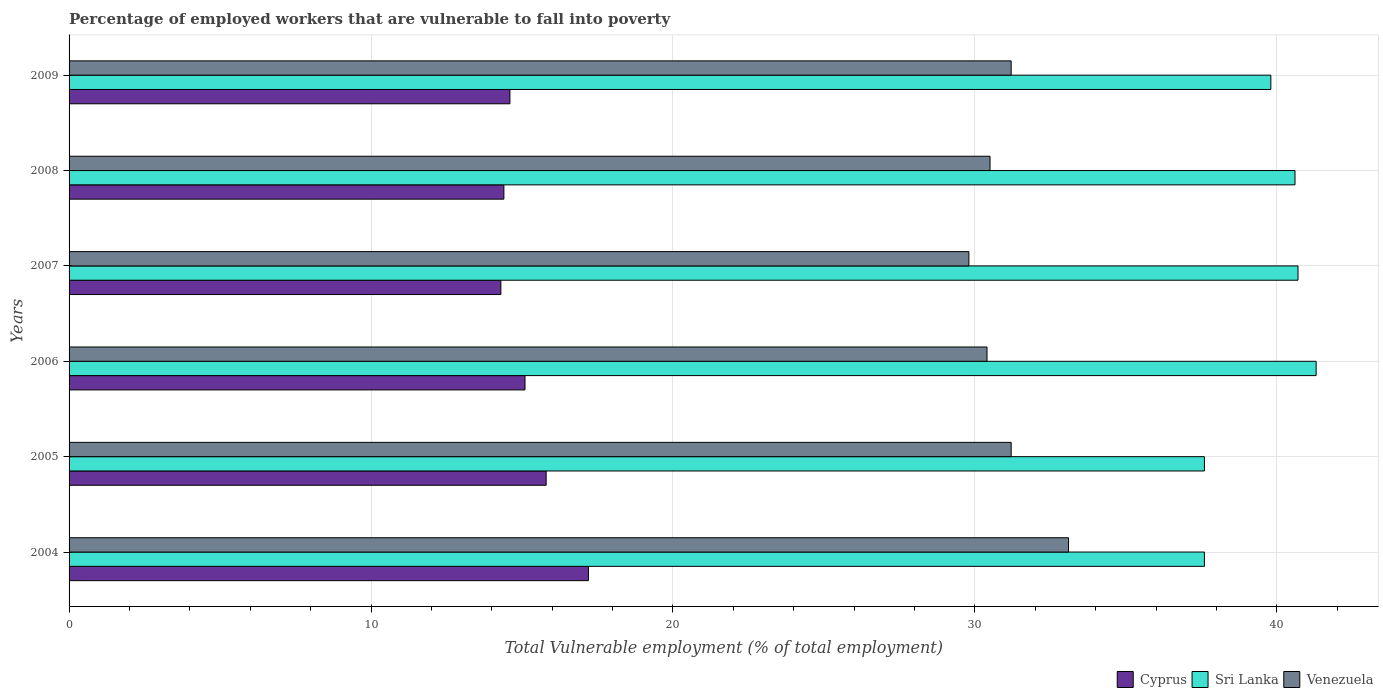How many different coloured bars are there?
Keep it short and to the point. 3. How many groups of bars are there?
Your answer should be compact. 6. Are the number of bars per tick equal to the number of legend labels?
Keep it short and to the point. Yes. What is the label of the 6th group of bars from the top?
Provide a short and direct response. 2004. What is the percentage of employed workers who are vulnerable to fall into poverty in Venezuela in 2009?
Keep it short and to the point. 31.2. Across all years, what is the maximum percentage of employed workers who are vulnerable to fall into poverty in Venezuela?
Ensure brevity in your answer.  33.1. Across all years, what is the minimum percentage of employed workers who are vulnerable to fall into poverty in Venezuela?
Offer a terse response. 29.8. In which year was the percentage of employed workers who are vulnerable to fall into poverty in Venezuela minimum?
Your answer should be very brief. 2007. What is the total percentage of employed workers who are vulnerable to fall into poverty in Venezuela in the graph?
Your answer should be very brief. 186.2. What is the difference between the percentage of employed workers who are vulnerable to fall into poverty in Sri Lanka in 2006 and that in 2007?
Make the answer very short. 0.6. What is the difference between the percentage of employed workers who are vulnerable to fall into poverty in Venezuela in 2009 and the percentage of employed workers who are vulnerable to fall into poverty in Cyprus in 2008?
Offer a terse response. 16.8. What is the average percentage of employed workers who are vulnerable to fall into poverty in Venezuela per year?
Give a very brief answer. 31.03. In the year 2008, what is the difference between the percentage of employed workers who are vulnerable to fall into poverty in Sri Lanka and percentage of employed workers who are vulnerable to fall into poverty in Venezuela?
Your response must be concise. 10.1. In how many years, is the percentage of employed workers who are vulnerable to fall into poverty in Sri Lanka greater than 38 %?
Your answer should be very brief. 4. What is the ratio of the percentage of employed workers who are vulnerable to fall into poverty in Cyprus in 2008 to that in 2009?
Ensure brevity in your answer.  0.99. What is the difference between the highest and the second highest percentage of employed workers who are vulnerable to fall into poverty in Venezuela?
Provide a short and direct response. 1.9. What is the difference between the highest and the lowest percentage of employed workers who are vulnerable to fall into poverty in Sri Lanka?
Keep it short and to the point. 3.7. Is the sum of the percentage of employed workers who are vulnerable to fall into poverty in Sri Lanka in 2005 and 2008 greater than the maximum percentage of employed workers who are vulnerable to fall into poverty in Venezuela across all years?
Provide a succinct answer. Yes. What does the 1st bar from the top in 2005 represents?
Offer a very short reply. Venezuela. What does the 3rd bar from the bottom in 2005 represents?
Ensure brevity in your answer.  Venezuela. Is it the case that in every year, the sum of the percentage of employed workers who are vulnerable to fall into poverty in Cyprus and percentage of employed workers who are vulnerable to fall into poverty in Sri Lanka is greater than the percentage of employed workers who are vulnerable to fall into poverty in Venezuela?
Your response must be concise. Yes. Are all the bars in the graph horizontal?
Your answer should be very brief. Yes. What is the difference between two consecutive major ticks on the X-axis?
Ensure brevity in your answer.  10. Are the values on the major ticks of X-axis written in scientific E-notation?
Provide a succinct answer. No. Does the graph contain grids?
Provide a short and direct response. Yes. How many legend labels are there?
Ensure brevity in your answer.  3. How are the legend labels stacked?
Offer a very short reply. Horizontal. What is the title of the graph?
Provide a short and direct response. Percentage of employed workers that are vulnerable to fall into poverty. Does "United Arab Emirates" appear as one of the legend labels in the graph?
Provide a short and direct response. No. What is the label or title of the X-axis?
Keep it short and to the point. Total Vulnerable employment (% of total employment). What is the label or title of the Y-axis?
Your answer should be compact. Years. What is the Total Vulnerable employment (% of total employment) in Cyprus in 2004?
Your answer should be very brief. 17.2. What is the Total Vulnerable employment (% of total employment) in Sri Lanka in 2004?
Keep it short and to the point. 37.6. What is the Total Vulnerable employment (% of total employment) in Venezuela in 2004?
Keep it short and to the point. 33.1. What is the Total Vulnerable employment (% of total employment) in Cyprus in 2005?
Offer a very short reply. 15.8. What is the Total Vulnerable employment (% of total employment) in Sri Lanka in 2005?
Your answer should be very brief. 37.6. What is the Total Vulnerable employment (% of total employment) of Venezuela in 2005?
Your answer should be compact. 31.2. What is the Total Vulnerable employment (% of total employment) in Cyprus in 2006?
Ensure brevity in your answer.  15.1. What is the Total Vulnerable employment (% of total employment) of Sri Lanka in 2006?
Provide a short and direct response. 41.3. What is the Total Vulnerable employment (% of total employment) in Venezuela in 2006?
Provide a short and direct response. 30.4. What is the Total Vulnerable employment (% of total employment) in Cyprus in 2007?
Provide a succinct answer. 14.3. What is the Total Vulnerable employment (% of total employment) of Sri Lanka in 2007?
Provide a short and direct response. 40.7. What is the Total Vulnerable employment (% of total employment) of Venezuela in 2007?
Provide a succinct answer. 29.8. What is the Total Vulnerable employment (% of total employment) of Cyprus in 2008?
Offer a very short reply. 14.4. What is the Total Vulnerable employment (% of total employment) of Sri Lanka in 2008?
Provide a short and direct response. 40.6. What is the Total Vulnerable employment (% of total employment) in Venezuela in 2008?
Your answer should be very brief. 30.5. What is the Total Vulnerable employment (% of total employment) of Cyprus in 2009?
Ensure brevity in your answer.  14.6. What is the Total Vulnerable employment (% of total employment) of Sri Lanka in 2009?
Give a very brief answer. 39.8. What is the Total Vulnerable employment (% of total employment) of Venezuela in 2009?
Ensure brevity in your answer.  31.2. Across all years, what is the maximum Total Vulnerable employment (% of total employment) of Cyprus?
Provide a short and direct response. 17.2. Across all years, what is the maximum Total Vulnerable employment (% of total employment) in Sri Lanka?
Make the answer very short. 41.3. Across all years, what is the maximum Total Vulnerable employment (% of total employment) in Venezuela?
Your answer should be very brief. 33.1. Across all years, what is the minimum Total Vulnerable employment (% of total employment) of Cyprus?
Your answer should be very brief. 14.3. Across all years, what is the minimum Total Vulnerable employment (% of total employment) of Sri Lanka?
Give a very brief answer. 37.6. Across all years, what is the minimum Total Vulnerable employment (% of total employment) in Venezuela?
Offer a terse response. 29.8. What is the total Total Vulnerable employment (% of total employment) in Cyprus in the graph?
Provide a succinct answer. 91.4. What is the total Total Vulnerable employment (% of total employment) in Sri Lanka in the graph?
Keep it short and to the point. 237.6. What is the total Total Vulnerable employment (% of total employment) in Venezuela in the graph?
Offer a terse response. 186.2. What is the difference between the Total Vulnerable employment (% of total employment) of Cyprus in 2004 and that in 2005?
Provide a succinct answer. 1.4. What is the difference between the Total Vulnerable employment (% of total employment) in Venezuela in 2004 and that in 2005?
Ensure brevity in your answer.  1.9. What is the difference between the Total Vulnerable employment (% of total employment) in Venezuela in 2004 and that in 2006?
Offer a very short reply. 2.7. What is the difference between the Total Vulnerable employment (% of total employment) of Cyprus in 2004 and that in 2007?
Offer a terse response. 2.9. What is the difference between the Total Vulnerable employment (% of total employment) in Sri Lanka in 2004 and that in 2007?
Your answer should be compact. -3.1. What is the difference between the Total Vulnerable employment (% of total employment) in Venezuela in 2004 and that in 2007?
Provide a succinct answer. 3.3. What is the difference between the Total Vulnerable employment (% of total employment) in Sri Lanka in 2004 and that in 2008?
Make the answer very short. -3. What is the difference between the Total Vulnerable employment (% of total employment) in Venezuela in 2004 and that in 2008?
Provide a short and direct response. 2.6. What is the difference between the Total Vulnerable employment (% of total employment) in Venezuela in 2004 and that in 2009?
Keep it short and to the point. 1.9. What is the difference between the Total Vulnerable employment (% of total employment) in Cyprus in 2005 and that in 2006?
Keep it short and to the point. 0.7. What is the difference between the Total Vulnerable employment (% of total employment) in Cyprus in 2005 and that in 2007?
Offer a very short reply. 1.5. What is the difference between the Total Vulnerable employment (% of total employment) of Venezuela in 2005 and that in 2007?
Your answer should be very brief. 1.4. What is the difference between the Total Vulnerable employment (% of total employment) of Sri Lanka in 2005 and that in 2008?
Your response must be concise. -3. What is the difference between the Total Vulnerable employment (% of total employment) in Sri Lanka in 2005 and that in 2009?
Offer a very short reply. -2.2. What is the difference between the Total Vulnerable employment (% of total employment) in Cyprus in 2006 and that in 2007?
Give a very brief answer. 0.8. What is the difference between the Total Vulnerable employment (% of total employment) in Sri Lanka in 2006 and that in 2008?
Provide a succinct answer. 0.7. What is the difference between the Total Vulnerable employment (% of total employment) of Venezuela in 2006 and that in 2008?
Your response must be concise. -0.1. What is the difference between the Total Vulnerable employment (% of total employment) in Sri Lanka in 2006 and that in 2009?
Provide a short and direct response. 1.5. What is the difference between the Total Vulnerable employment (% of total employment) of Venezuela in 2006 and that in 2009?
Provide a succinct answer. -0.8. What is the difference between the Total Vulnerable employment (% of total employment) in Sri Lanka in 2007 and that in 2008?
Your response must be concise. 0.1. What is the difference between the Total Vulnerable employment (% of total employment) in Venezuela in 2007 and that in 2008?
Offer a terse response. -0.7. What is the difference between the Total Vulnerable employment (% of total employment) of Cyprus in 2007 and that in 2009?
Your response must be concise. -0.3. What is the difference between the Total Vulnerable employment (% of total employment) in Sri Lanka in 2007 and that in 2009?
Ensure brevity in your answer.  0.9. What is the difference between the Total Vulnerable employment (% of total employment) of Venezuela in 2007 and that in 2009?
Offer a terse response. -1.4. What is the difference between the Total Vulnerable employment (% of total employment) in Cyprus in 2008 and that in 2009?
Ensure brevity in your answer.  -0.2. What is the difference between the Total Vulnerable employment (% of total employment) in Sri Lanka in 2008 and that in 2009?
Your response must be concise. 0.8. What is the difference between the Total Vulnerable employment (% of total employment) in Venezuela in 2008 and that in 2009?
Keep it short and to the point. -0.7. What is the difference between the Total Vulnerable employment (% of total employment) of Cyprus in 2004 and the Total Vulnerable employment (% of total employment) of Sri Lanka in 2005?
Provide a succinct answer. -20.4. What is the difference between the Total Vulnerable employment (% of total employment) in Sri Lanka in 2004 and the Total Vulnerable employment (% of total employment) in Venezuela in 2005?
Your response must be concise. 6.4. What is the difference between the Total Vulnerable employment (% of total employment) in Cyprus in 2004 and the Total Vulnerable employment (% of total employment) in Sri Lanka in 2006?
Ensure brevity in your answer.  -24.1. What is the difference between the Total Vulnerable employment (% of total employment) in Cyprus in 2004 and the Total Vulnerable employment (% of total employment) in Venezuela in 2006?
Offer a terse response. -13.2. What is the difference between the Total Vulnerable employment (% of total employment) of Cyprus in 2004 and the Total Vulnerable employment (% of total employment) of Sri Lanka in 2007?
Your answer should be very brief. -23.5. What is the difference between the Total Vulnerable employment (% of total employment) in Sri Lanka in 2004 and the Total Vulnerable employment (% of total employment) in Venezuela in 2007?
Make the answer very short. 7.8. What is the difference between the Total Vulnerable employment (% of total employment) of Cyprus in 2004 and the Total Vulnerable employment (% of total employment) of Sri Lanka in 2008?
Keep it short and to the point. -23.4. What is the difference between the Total Vulnerable employment (% of total employment) in Cyprus in 2004 and the Total Vulnerable employment (% of total employment) in Venezuela in 2008?
Your answer should be compact. -13.3. What is the difference between the Total Vulnerable employment (% of total employment) in Cyprus in 2004 and the Total Vulnerable employment (% of total employment) in Sri Lanka in 2009?
Your answer should be compact. -22.6. What is the difference between the Total Vulnerable employment (% of total employment) in Cyprus in 2004 and the Total Vulnerable employment (% of total employment) in Venezuela in 2009?
Provide a short and direct response. -14. What is the difference between the Total Vulnerable employment (% of total employment) in Cyprus in 2005 and the Total Vulnerable employment (% of total employment) in Sri Lanka in 2006?
Offer a terse response. -25.5. What is the difference between the Total Vulnerable employment (% of total employment) in Cyprus in 2005 and the Total Vulnerable employment (% of total employment) in Venezuela in 2006?
Your answer should be very brief. -14.6. What is the difference between the Total Vulnerable employment (% of total employment) in Sri Lanka in 2005 and the Total Vulnerable employment (% of total employment) in Venezuela in 2006?
Your response must be concise. 7.2. What is the difference between the Total Vulnerable employment (% of total employment) in Cyprus in 2005 and the Total Vulnerable employment (% of total employment) in Sri Lanka in 2007?
Offer a very short reply. -24.9. What is the difference between the Total Vulnerable employment (% of total employment) in Cyprus in 2005 and the Total Vulnerable employment (% of total employment) in Venezuela in 2007?
Your response must be concise. -14. What is the difference between the Total Vulnerable employment (% of total employment) of Cyprus in 2005 and the Total Vulnerable employment (% of total employment) of Sri Lanka in 2008?
Ensure brevity in your answer.  -24.8. What is the difference between the Total Vulnerable employment (% of total employment) of Cyprus in 2005 and the Total Vulnerable employment (% of total employment) of Venezuela in 2008?
Your answer should be compact. -14.7. What is the difference between the Total Vulnerable employment (% of total employment) in Cyprus in 2005 and the Total Vulnerable employment (% of total employment) in Sri Lanka in 2009?
Offer a very short reply. -24. What is the difference between the Total Vulnerable employment (% of total employment) in Cyprus in 2005 and the Total Vulnerable employment (% of total employment) in Venezuela in 2009?
Offer a terse response. -15.4. What is the difference between the Total Vulnerable employment (% of total employment) of Sri Lanka in 2005 and the Total Vulnerable employment (% of total employment) of Venezuela in 2009?
Ensure brevity in your answer.  6.4. What is the difference between the Total Vulnerable employment (% of total employment) in Cyprus in 2006 and the Total Vulnerable employment (% of total employment) in Sri Lanka in 2007?
Keep it short and to the point. -25.6. What is the difference between the Total Vulnerable employment (% of total employment) of Cyprus in 2006 and the Total Vulnerable employment (% of total employment) of Venezuela in 2007?
Your answer should be very brief. -14.7. What is the difference between the Total Vulnerable employment (% of total employment) of Cyprus in 2006 and the Total Vulnerable employment (% of total employment) of Sri Lanka in 2008?
Make the answer very short. -25.5. What is the difference between the Total Vulnerable employment (% of total employment) of Cyprus in 2006 and the Total Vulnerable employment (% of total employment) of Venezuela in 2008?
Your answer should be compact. -15.4. What is the difference between the Total Vulnerable employment (% of total employment) of Cyprus in 2006 and the Total Vulnerable employment (% of total employment) of Sri Lanka in 2009?
Keep it short and to the point. -24.7. What is the difference between the Total Vulnerable employment (% of total employment) in Cyprus in 2006 and the Total Vulnerable employment (% of total employment) in Venezuela in 2009?
Keep it short and to the point. -16.1. What is the difference between the Total Vulnerable employment (% of total employment) of Cyprus in 2007 and the Total Vulnerable employment (% of total employment) of Sri Lanka in 2008?
Keep it short and to the point. -26.3. What is the difference between the Total Vulnerable employment (% of total employment) in Cyprus in 2007 and the Total Vulnerable employment (% of total employment) in Venezuela in 2008?
Ensure brevity in your answer.  -16.2. What is the difference between the Total Vulnerable employment (% of total employment) of Sri Lanka in 2007 and the Total Vulnerable employment (% of total employment) of Venezuela in 2008?
Provide a succinct answer. 10.2. What is the difference between the Total Vulnerable employment (% of total employment) in Cyprus in 2007 and the Total Vulnerable employment (% of total employment) in Sri Lanka in 2009?
Your answer should be compact. -25.5. What is the difference between the Total Vulnerable employment (% of total employment) in Cyprus in 2007 and the Total Vulnerable employment (% of total employment) in Venezuela in 2009?
Make the answer very short. -16.9. What is the difference between the Total Vulnerable employment (% of total employment) in Cyprus in 2008 and the Total Vulnerable employment (% of total employment) in Sri Lanka in 2009?
Keep it short and to the point. -25.4. What is the difference between the Total Vulnerable employment (% of total employment) in Cyprus in 2008 and the Total Vulnerable employment (% of total employment) in Venezuela in 2009?
Provide a short and direct response. -16.8. What is the difference between the Total Vulnerable employment (% of total employment) in Sri Lanka in 2008 and the Total Vulnerable employment (% of total employment) in Venezuela in 2009?
Make the answer very short. 9.4. What is the average Total Vulnerable employment (% of total employment) in Cyprus per year?
Keep it short and to the point. 15.23. What is the average Total Vulnerable employment (% of total employment) of Sri Lanka per year?
Provide a short and direct response. 39.6. What is the average Total Vulnerable employment (% of total employment) in Venezuela per year?
Make the answer very short. 31.03. In the year 2004, what is the difference between the Total Vulnerable employment (% of total employment) of Cyprus and Total Vulnerable employment (% of total employment) of Sri Lanka?
Offer a very short reply. -20.4. In the year 2004, what is the difference between the Total Vulnerable employment (% of total employment) of Cyprus and Total Vulnerable employment (% of total employment) of Venezuela?
Keep it short and to the point. -15.9. In the year 2005, what is the difference between the Total Vulnerable employment (% of total employment) of Cyprus and Total Vulnerable employment (% of total employment) of Sri Lanka?
Your answer should be very brief. -21.8. In the year 2005, what is the difference between the Total Vulnerable employment (% of total employment) of Cyprus and Total Vulnerable employment (% of total employment) of Venezuela?
Make the answer very short. -15.4. In the year 2005, what is the difference between the Total Vulnerable employment (% of total employment) in Sri Lanka and Total Vulnerable employment (% of total employment) in Venezuela?
Offer a very short reply. 6.4. In the year 2006, what is the difference between the Total Vulnerable employment (% of total employment) of Cyprus and Total Vulnerable employment (% of total employment) of Sri Lanka?
Make the answer very short. -26.2. In the year 2006, what is the difference between the Total Vulnerable employment (% of total employment) of Cyprus and Total Vulnerable employment (% of total employment) of Venezuela?
Offer a terse response. -15.3. In the year 2006, what is the difference between the Total Vulnerable employment (% of total employment) of Sri Lanka and Total Vulnerable employment (% of total employment) of Venezuela?
Offer a terse response. 10.9. In the year 2007, what is the difference between the Total Vulnerable employment (% of total employment) in Cyprus and Total Vulnerable employment (% of total employment) in Sri Lanka?
Your answer should be compact. -26.4. In the year 2007, what is the difference between the Total Vulnerable employment (% of total employment) in Cyprus and Total Vulnerable employment (% of total employment) in Venezuela?
Your response must be concise. -15.5. In the year 2007, what is the difference between the Total Vulnerable employment (% of total employment) in Sri Lanka and Total Vulnerable employment (% of total employment) in Venezuela?
Make the answer very short. 10.9. In the year 2008, what is the difference between the Total Vulnerable employment (% of total employment) of Cyprus and Total Vulnerable employment (% of total employment) of Sri Lanka?
Your response must be concise. -26.2. In the year 2008, what is the difference between the Total Vulnerable employment (% of total employment) of Cyprus and Total Vulnerable employment (% of total employment) of Venezuela?
Give a very brief answer. -16.1. In the year 2009, what is the difference between the Total Vulnerable employment (% of total employment) of Cyprus and Total Vulnerable employment (% of total employment) of Sri Lanka?
Keep it short and to the point. -25.2. In the year 2009, what is the difference between the Total Vulnerable employment (% of total employment) of Cyprus and Total Vulnerable employment (% of total employment) of Venezuela?
Ensure brevity in your answer.  -16.6. In the year 2009, what is the difference between the Total Vulnerable employment (% of total employment) in Sri Lanka and Total Vulnerable employment (% of total employment) in Venezuela?
Your answer should be very brief. 8.6. What is the ratio of the Total Vulnerable employment (% of total employment) in Cyprus in 2004 to that in 2005?
Make the answer very short. 1.09. What is the ratio of the Total Vulnerable employment (% of total employment) in Venezuela in 2004 to that in 2005?
Provide a short and direct response. 1.06. What is the ratio of the Total Vulnerable employment (% of total employment) of Cyprus in 2004 to that in 2006?
Make the answer very short. 1.14. What is the ratio of the Total Vulnerable employment (% of total employment) of Sri Lanka in 2004 to that in 2006?
Provide a succinct answer. 0.91. What is the ratio of the Total Vulnerable employment (% of total employment) of Venezuela in 2004 to that in 2006?
Give a very brief answer. 1.09. What is the ratio of the Total Vulnerable employment (% of total employment) in Cyprus in 2004 to that in 2007?
Keep it short and to the point. 1.2. What is the ratio of the Total Vulnerable employment (% of total employment) of Sri Lanka in 2004 to that in 2007?
Ensure brevity in your answer.  0.92. What is the ratio of the Total Vulnerable employment (% of total employment) of Venezuela in 2004 to that in 2007?
Provide a short and direct response. 1.11. What is the ratio of the Total Vulnerable employment (% of total employment) of Cyprus in 2004 to that in 2008?
Offer a very short reply. 1.19. What is the ratio of the Total Vulnerable employment (% of total employment) in Sri Lanka in 2004 to that in 2008?
Ensure brevity in your answer.  0.93. What is the ratio of the Total Vulnerable employment (% of total employment) in Venezuela in 2004 to that in 2008?
Offer a very short reply. 1.09. What is the ratio of the Total Vulnerable employment (% of total employment) in Cyprus in 2004 to that in 2009?
Your response must be concise. 1.18. What is the ratio of the Total Vulnerable employment (% of total employment) in Sri Lanka in 2004 to that in 2009?
Make the answer very short. 0.94. What is the ratio of the Total Vulnerable employment (% of total employment) in Venezuela in 2004 to that in 2009?
Ensure brevity in your answer.  1.06. What is the ratio of the Total Vulnerable employment (% of total employment) of Cyprus in 2005 to that in 2006?
Provide a succinct answer. 1.05. What is the ratio of the Total Vulnerable employment (% of total employment) in Sri Lanka in 2005 to that in 2006?
Provide a succinct answer. 0.91. What is the ratio of the Total Vulnerable employment (% of total employment) of Venezuela in 2005 to that in 2006?
Ensure brevity in your answer.  1.03. What is the ratio of the Total Vulnerable employment (% of total employment) of Cyprus in 2005 to that in 2007?
Your answer should be compact. 1.1. What is the ratio of the Total Vulnerable employment (% of total employment) in Sri Lanka in 2005 to that in 2007?
Provide a succinct answer. 0.92. What is the ratio of the Total Vulnerable employment (% of total employment) in Venezuela in 2005 to that in 2007?
Provide a succinct answer. 1.05. What is the ratio of the Total Vulnerable employment (% of total employment) of Cyprus in 2005 to that in 2008?
Give a very brief answer. 1.1. What is the ratio of the Total Vulnerable employment (% of total employment) of Sri Lanka in 2005 to that in 2008?
Your response must be concise. 0.93. What is the ratio of the Total Vulnerable employment (% of total employment) of Cyprus in 2005 to that in 2009?
Keep it short and to the point. 1.08. What is the ratio of the Total Vulnerable employment (% of total employment) in Sri Lanka in 2005 to that in 2009?
Offer a very short reply. 0.94. What is the ratio of the Total Vulnerable employment (% of total employment) of Cyprus in 2006 to that in 2007?
Your answer should be compact. 1.06. What is the ratio of the Total Vulnerable employment (% of total employment) in Sri Lanka in 2006 to that in 2007?
Give a very brief answer. 1.01. What is the ratio of the Total Vulnerable employment (% of total employment) of Venezuela in 2006 to that in 2007?
Ensure brevity in your answer.  1.02. What is the ratio of the Total Vulnerable employment (% of total employment) of Cyprus in 2006 to that in 2008?
Make the answer very short. 1.05. What is the ratio of the Total Vulnerable employment (% of total employment) of Sri Lanka in 2006 to that in 2008?
Your answer should be very brief. 1.02. What is the ratio of the Total Vulnerable employment (% of total employment) of Venezuela in 2006 to that in 2008?
Make the answer very short. 1. What is the ratio of the Total Vulnerable employment (% of total employment) of Cyprus in 2006 to that in 2009?
Offer a very short reply. 1.03. What is the ratio of the Total Vulnerable employment (% of total employment) of Sri Lanka in 2006 to that in 2009?
Provide a succinct answer. 1.04. What is the ratio of the Total Vulnerable employment (% of total employment) of Venezuela in 2006 to that in 2009?
Give a very brief answer. 0.97. What is the ratio of the Total Vulnerable employment (% of total employment) of Cyprus in 2007 to that in 2008?
Provide a short and direct response. 0.99. What is the ratio of the Total Vulnerable employment (% of total employment) in Venezuela in 2007 to that in 2008?
Offer a very short reply. 0.98. What is the ratio of the Total Vulnerable employment (% of total employment) in Cyprus in 2007 to that in 2009?
Make the answer very short. 0.98. What is the ratio of the Total Vulnerable employment (% of total employment) in Sri Lanka in 2007 to that in 2009?
Make the answer very short. 1.02. What is the ratio of the Total Vulnerable employment (% of total employment) of Venezuela in 2007 to that in 2009?
Keep it short and to the point. 0.96. What is the ratio of the Total Vulnerable employment (% of total employment) of Cyprus in 2008 to that in 2009?
Make the answer very short. 0.99. What is the ratio of the Total Vulnerable employment (% of total employment) in Sri Lanka in 2008 to that in 2009?
Your answer should be very brief. 1.02. What is the ratio of the Total Vulnerable employment (% of total employment) in Venezuela in 2008 to that in 2009?
Ensure brevity in your answer.  0.98. What is the difference between the highest and the second highest Total Vulnerable employment (% of total employment) in Cyprus?
Your answer should be very brief. 1.4. What is the difference between the highest and the lowest Total Vulnerable employment (% of total employment) in Cyprus?
Give a very brief answer. 2.9. What is the difference between the highest and the lowest Total Vulnerable employment (% of total employment) in Sri Lanka?
Offer a terse response. 3.7. What is the difference between the highest and the lowest Total Vulnerable employment (% of total employment) of Venezuela?
Provide a short and direct response. 3.3. 